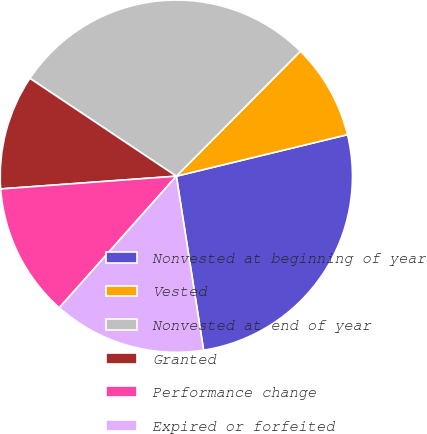Convert chart to OTSL. <chart><loc_0><loc_0><loc_500><loc_500><pie_chart><fcel>Nonvested at beginning of year<fcel>Vested<fcel>Nonvested at end of year<fcel>Granted<fcel>Performance change<fcel>Expired or forfeited<nl><fcel>26.32%<fcel>8.77%<fcel>28.07%<fcel>10.53%<fcel>12.28%<fcel>14.04%<nl></chart> 